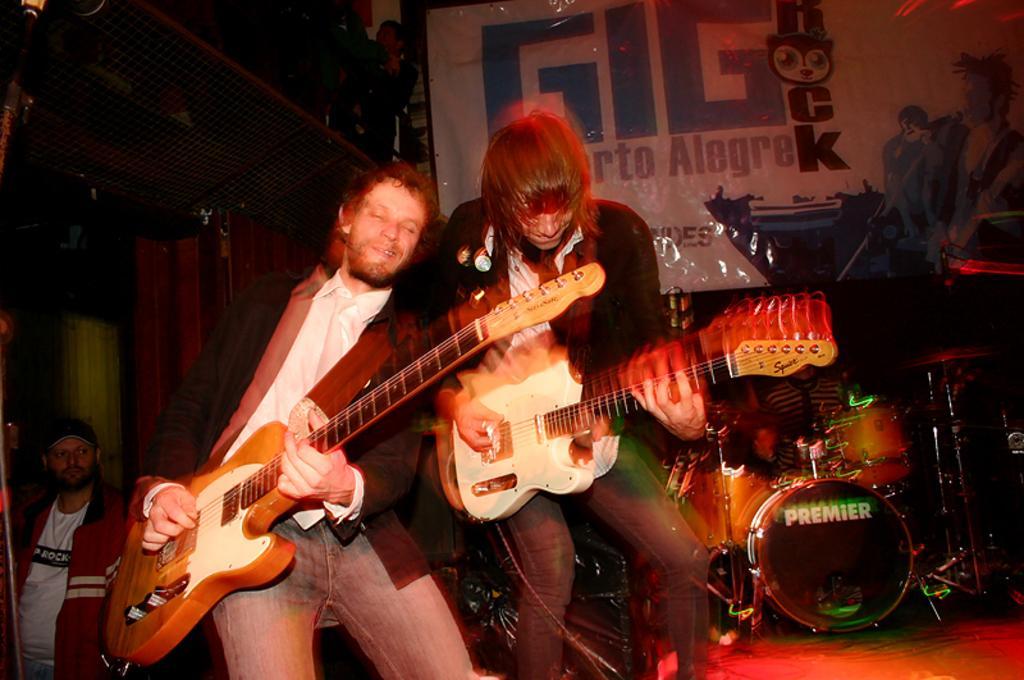How would you summarize this image in a sentence or two? There are two men playing guitar. Behind them there are people and musical instruments. 